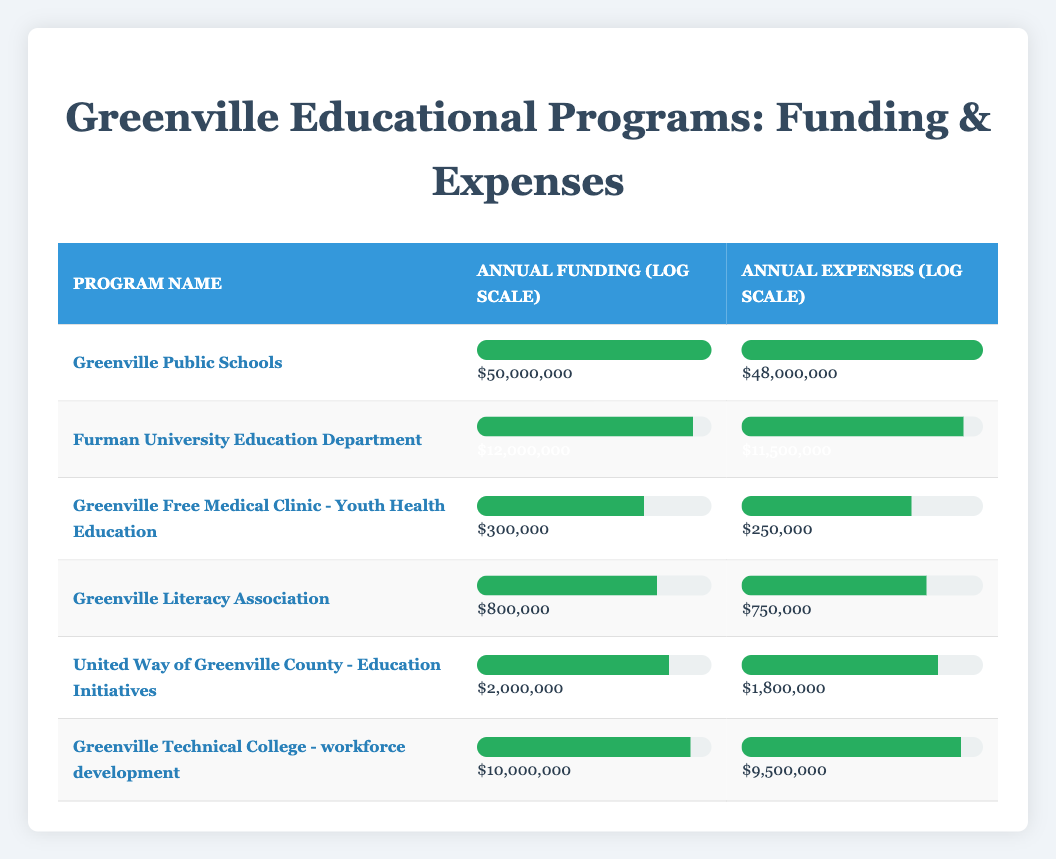What is the annual funding for Greenville Public Schools? The table shows that the annual funding for Greenville Public Schools is listed directly under the "Annual Funding (log scale)" column. The corresponding value is $50,000,000.
Answer: $50,000,000 Which program has the highest annual expenses? By looking at the "Annual Expenses (log scale)" column in the table, Greenville Public Schools has the highest annual expenses at $48,000,000 compared to other programs.
Answer: Greenville Public Schools What is the difference between the annual funding and expenses for Furman University Education Department? The annual funding for Furman University Education Department is $12,000,000, and the annual expenses are $11,500,000. To find the difference, we subtract the expenses from the funding: $12,000,000 - $11,500,000 = $500,000.
Answer: $500,000 Is the annual funding for Greenville Literacy Association greater than that of Greenville Free Medical Clinic? Greenville Literacy Association has an annual funding of $800,000 while Greenville Free Medical Clinic has $300,000. Since $800,000 is greater than $300,000, the answer is yes.
Answer: Yes What is the average annual funding for the educational programs listed? To calculate the average annual funding, we need to sum up all the annual funding values: $50,000,000 + $12,000,000 + $300,000 + $800,000 + $2,000,000 + $10,000,000 = $75,102,000. There are 6 programs, so the average is $75,102,000 divided by 6, which equals $12,517,000.
Answer: $12,517,000 How much more funding does Greenville Technical College receive compared to United Way of Greenville County? The funding for Greenville Technical College is $10,000,000 and for United Way of Greenville County is $2,000,000. The difference is calculated by subtracting the funding for United Way from that of Greenville Technical College: $10,000,000 - $2,000,000 = $8,000,000.
Answer: $8,000,000 Which program has the lowest annual expenses? Looking through the "Annual Expenses (log scale)" column, Greenville Free Medical Clinic has the lowest expenses at $250,000 compared to others.
Answer: Greenville Free Medical Clinic Does the total annual funding of educational programs exceed $70 million? First, we sum the annual funding: $50,000,000 + $12,000,000 + $300,000 + $800,000 + $2,000,000 + $10,000,000 = $75,102,000. Since $75,102,000 is greater than $70 million, the answer is yes.
Answer: Yes 